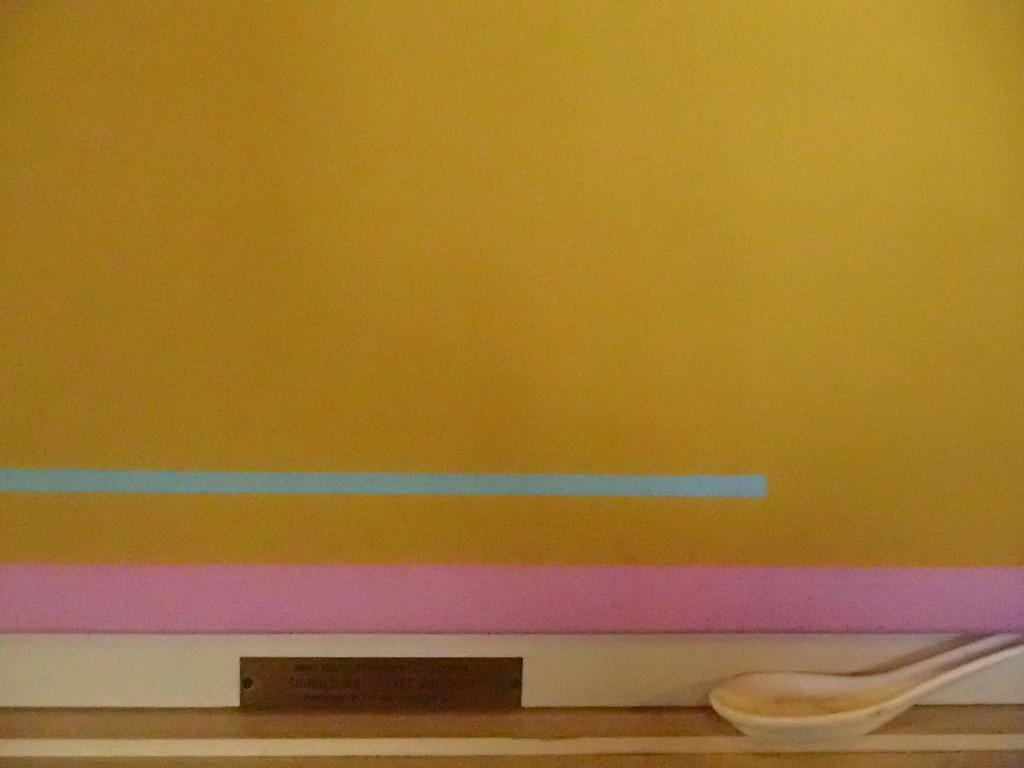What object is present on the table in the image? There is a spoon on the table in the image. What type of unit is being measured by the turkey on the table in the image? There is no turkey present in the image, and therefore no unit measurement can be observed. 